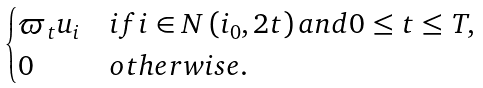Convert formula to latex. <formula><loc_0><loc_0><loc_500><loc_500>\begin{cases} \varpi _ { t } u _ { i } & i f i \in N \left ( i _ { 0 } , 2 t \right ) a n d 0 \leq t \leq T , \\ 0 & o t h e r w i s e . \end{cases}</formula> 